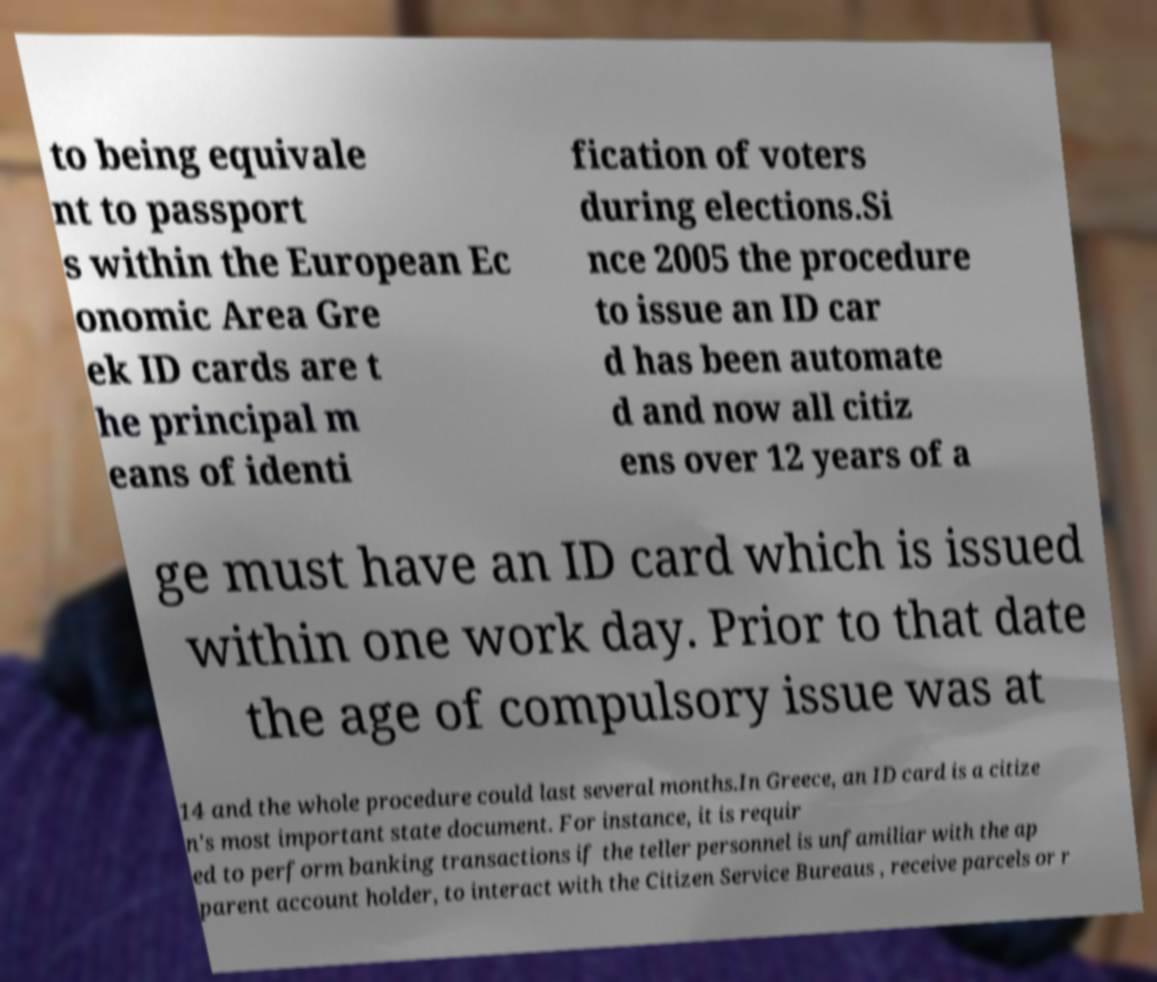I need the written content from this picture converted into text. Can you do that? to being equivale nt to passport s within the European Ec onomic Area Gre ek ID cards are t he principal m eans of identi fication of voters during elections.Si nce 2005 the procedure to issue an ID car d has been automate d and now all citiz ens over 12 years of a ge must have an ID card which is issued within one work day. Prior to that date the age of compulsory issue was at 14 and the whole procedure could last several months.In Greece, an ID card is a citize n's most important state document. For instance, it is requir ed to perform banking transactions if the teller personnel is unfamiliar with the ap parent account holder, to interact with the Citizen Service Bureaus , receive parcels or r 